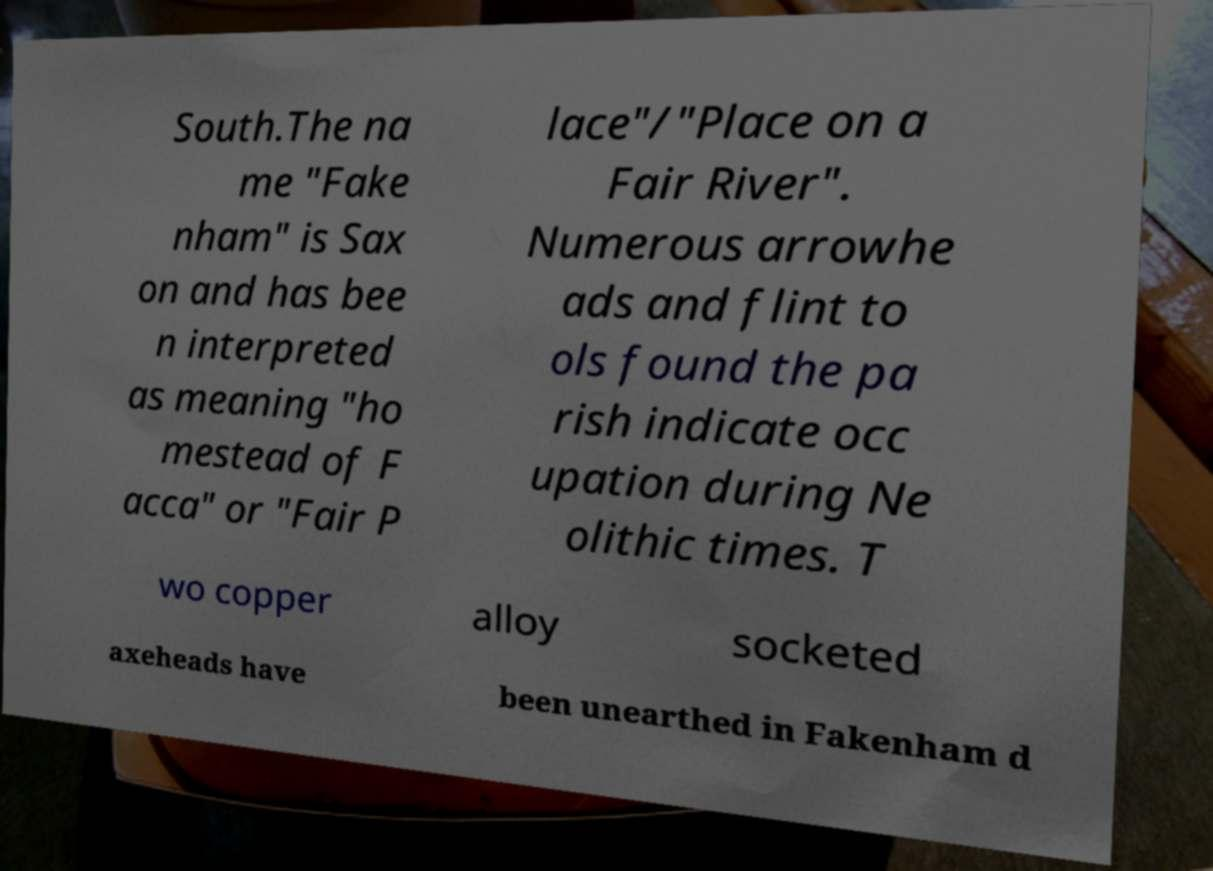There's text embedded in this image that I need extracted. Can you transcribe it verbatim? South.The na me "Fake nham" is Sax on and has bee n interpreted as meaning "ho mestead of F acca" or "Fair P lace"/"Place on a Fair River". Numerous arrowhe ads and flint to ols found the pa rish indicate occ upation during Ne olithic times. T wo copper alloy socketed axeheads have been unearthed in Fakenham d 